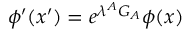Convert formula to latex. <formula><loc_0><loc_0><loc_500><loc_500>\phi ^ { \prime } ( x ^ { \prime } ) = e ^ { \lambda ^ { A } G _ { A } } \phi ( x )</formula> 